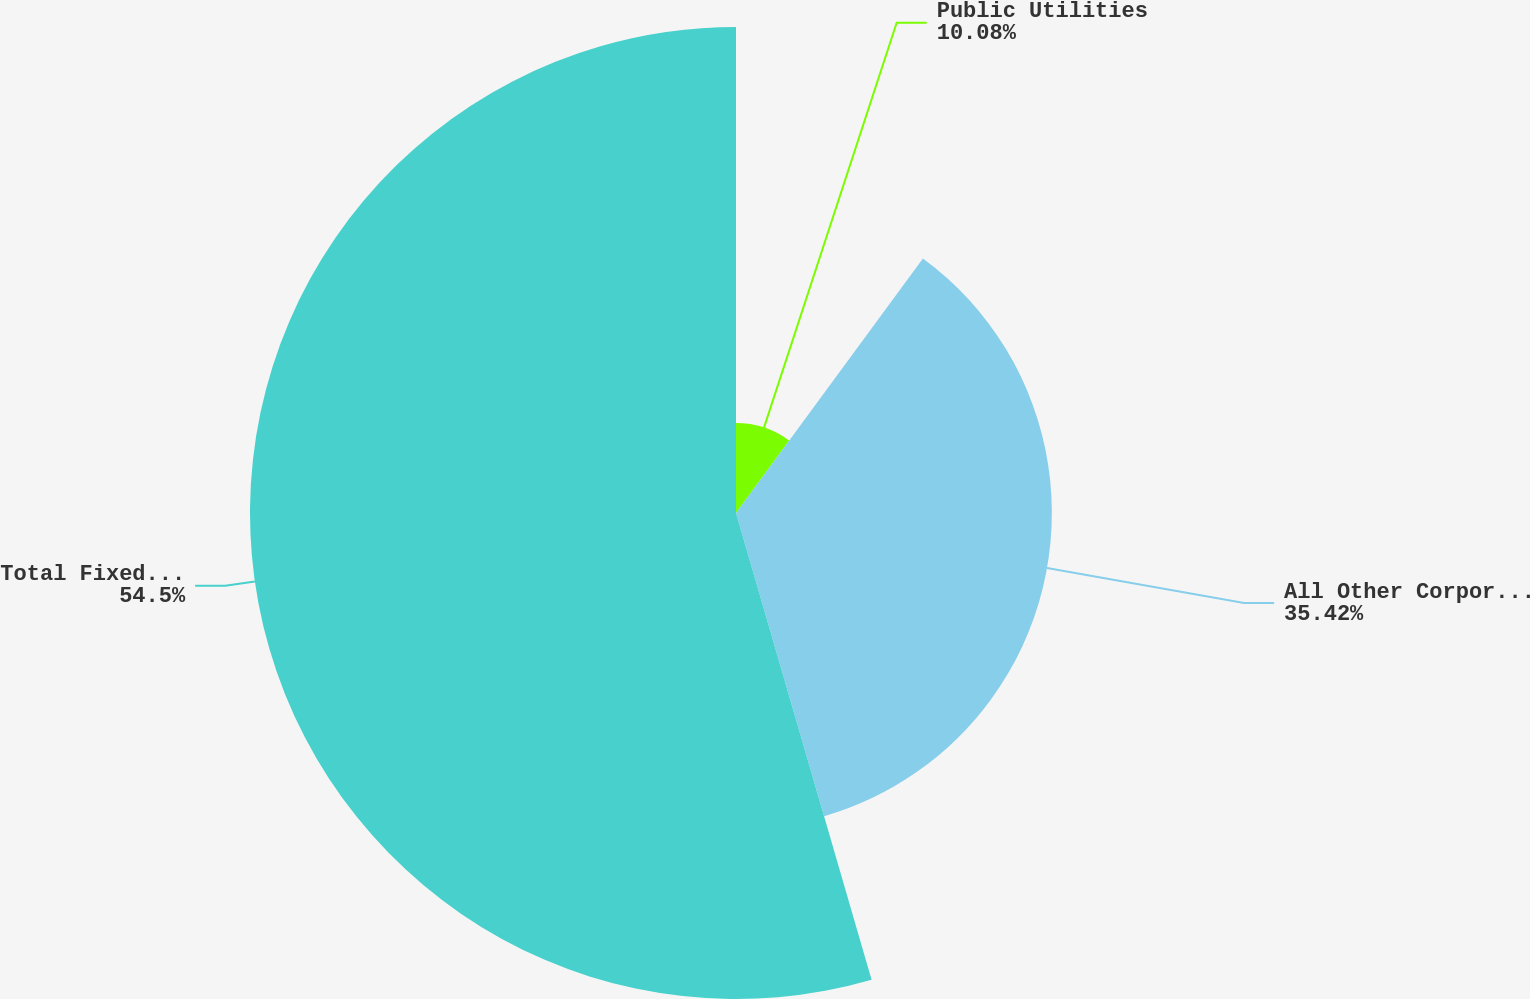<chart> <loc_0><loc_0><loc_500><loc_500><pie_chart><fcel>Public Utilities<fcel>All Other Corporate Bonds<fcel>Total Fixed Maturity<nl><fcel>10.08%<fcel>35.42%<fcel>54.5%<nl></chart> 